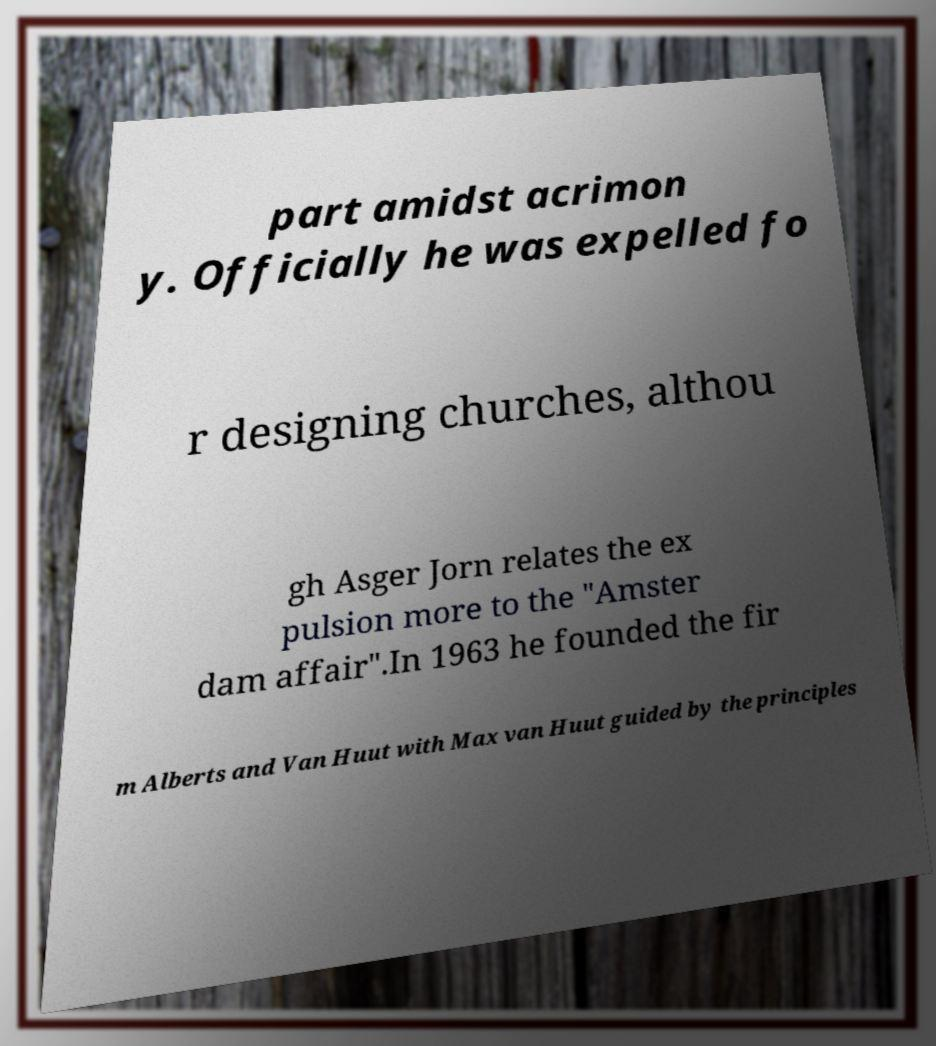What messages or text are displayed in this image? I need them in a readable, typed format. part amidst acrimon y. Officially he was expelled fo r designing churches, althou gh Asger Jorn relates the ex pulsion more to the "Amster dam affair".In 1963 he founded the fir m Alberts and Van Huut with Max van Huut guided by the principles 